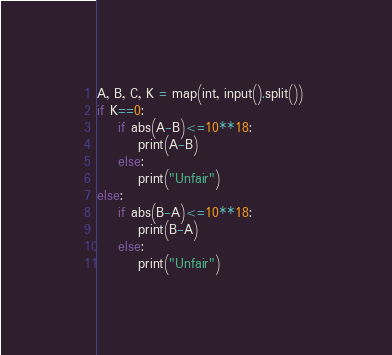<code> <loc_0><loc_0><loc_500><loc_500><_Python_>A, B, C, K = map(int, input().split()) 
if K==0:
    if abs(A-B)<=10**18:
        print(A-B)
    else:
        print("Unfair")
else:
    if abs(B-A)<=10**18:
        print(B-A)
    else:
        print("Unfair")</code> 